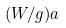<formula> <loc_0><loc_0><loc_500><loc_500>( W / g ) a</formula> 